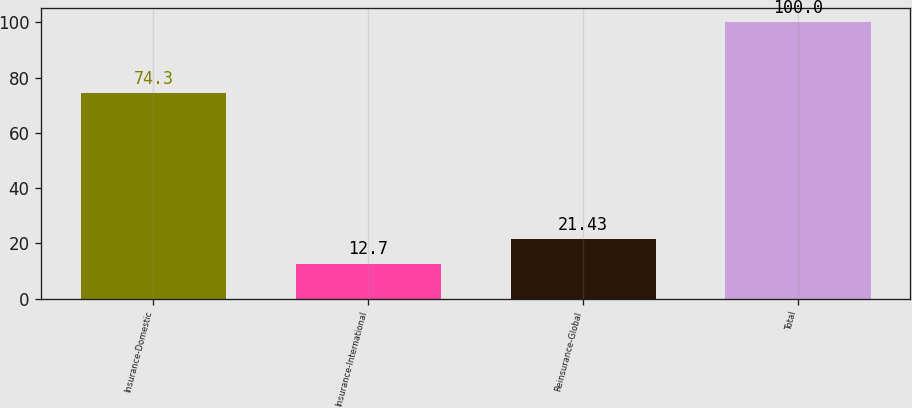Convert chart to OTSL. <chart><loc_0><loc_0><loc_500><loc_500><bar_chart><fcel>Insurance-Domestic<fcel>Insurance-International<fcel>Reinsurance-Global<fcel>Total<nl><fcel>74.3<fcel>12.7<fcel>21.43<fcel>100<nl></chart> 